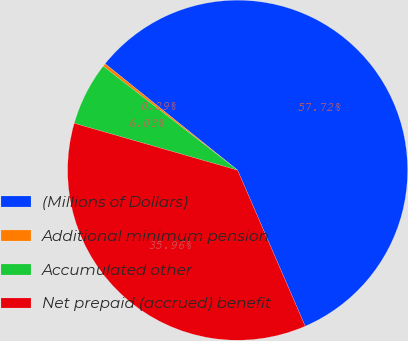<chart> <loc_0><loc_0><loc_500><loc_500><pie_chart><fcel>(Millions of Dollars)<fcel>Additional minimum pension<fcel>Accumulated other<fcel>Net prepaid (accrued) benefit<nl><fcel>57.72%<fcel>0.29%<fcel>6.03%<fcel>35.96%<nl></chart> 